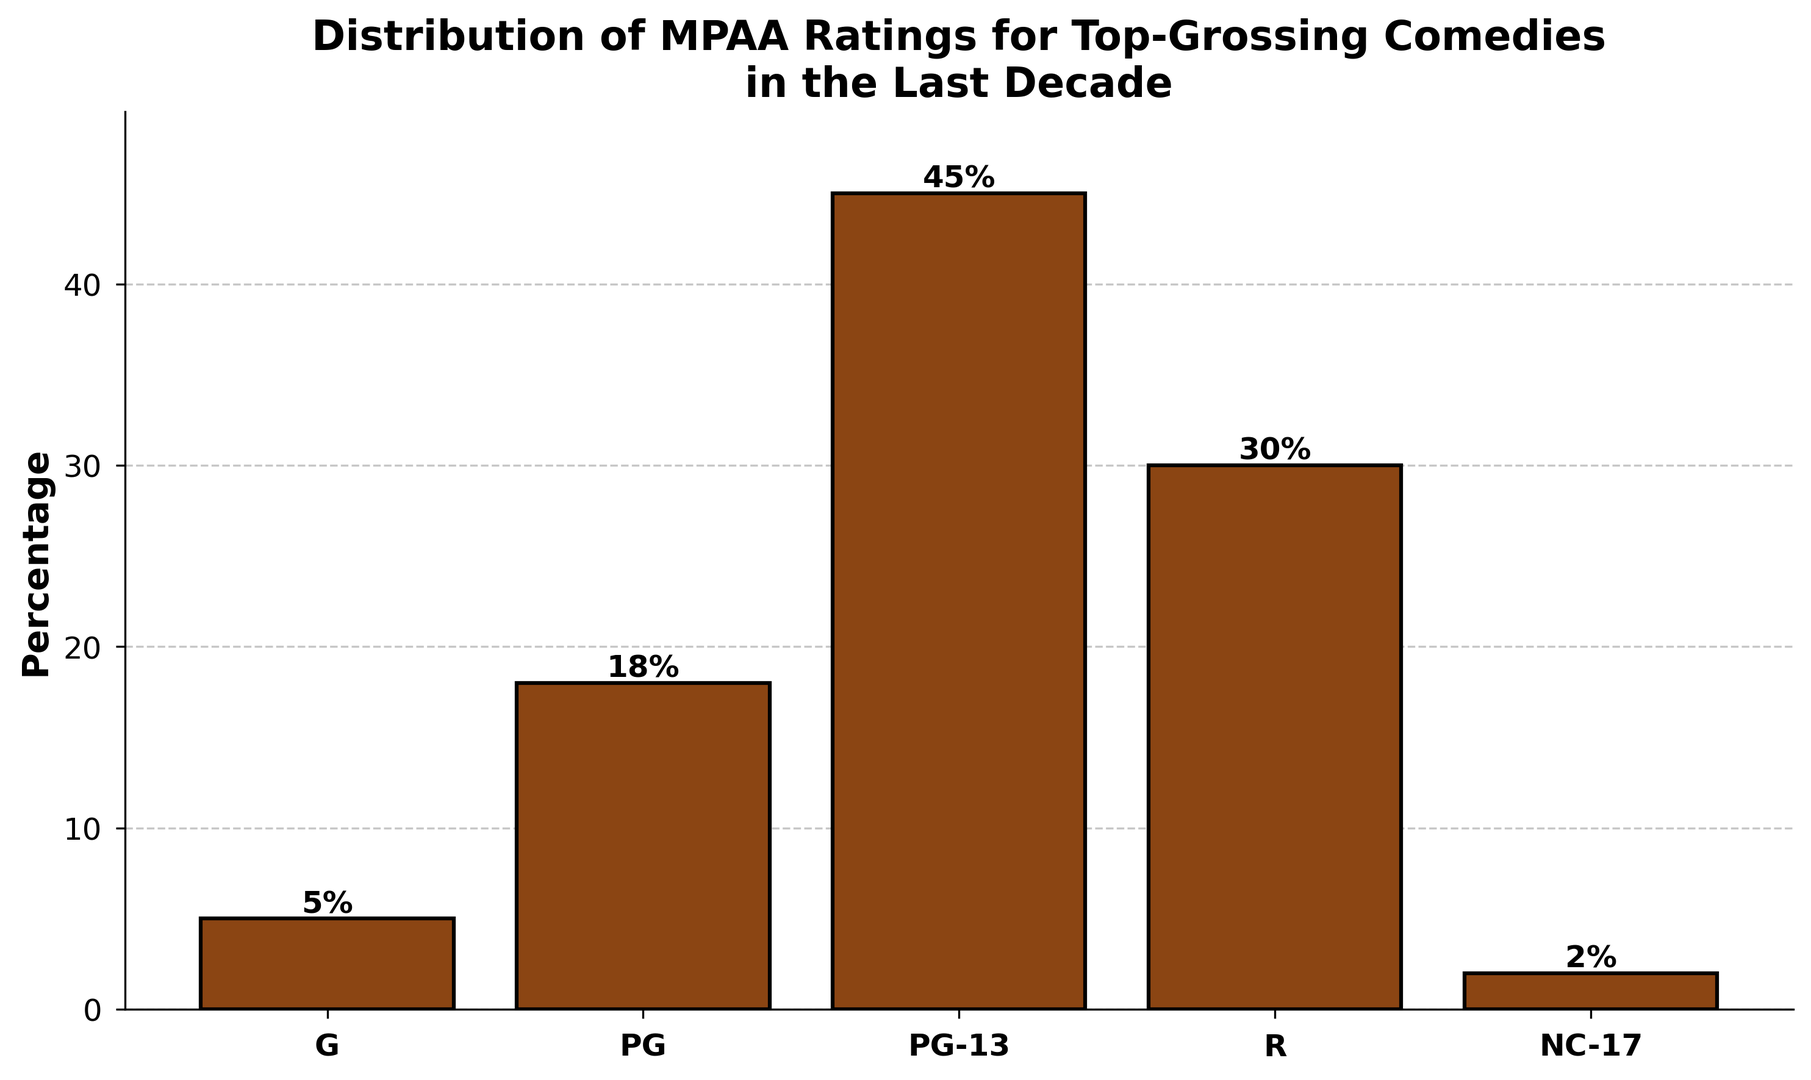What percentage of top-grossing comedies have a PG-13 rating? The bar labeled "PG-13" has a height indicating 45%.
Answer: 45% What is the total percentage of top-grossing comedies that are rated G or PG? The bar labeled "G" indicates 5%, and the bar labeled "PG" indicates 18%. Adding them together: 5% + 18% = 23%
Answer: 23% Which rating category has the smallest percentage of top-grossing comedies? The bar labeled "NC-17" has the smallest height, which is 2%.
Answer: NC-17 By how much does the percentage of PG-13 rated comedies exceed that of R-rated comedies? The bar labeled "PG-13" is 45%, and the bar labeled "R" is 30%. The difference is: 45% - 30% = 15%
Answer: 15% What is the combined percentage of top-grossing comedies that are rated either R or NC-17? The bar labeled "R" is 30%, and the bar labeled "NC-17" is 2%. Adding them together: 30% + 2% = 32%
Answer: 32% Among G, PG, and PG-13 rated comedies, which rating dominates the distribution? The bar labeled "PG-13" has the largest height among G (5%), PG (18%), and PG-13 (45%).
Answer: PG-13 What is the difference in percentage points between the most frequent rating and the least frequent rating? The most frequent rating is PG-13 at 45%, and the least frequent is NC-17 at 2%. The difference is: 45% - 2% = 43%
Answer: 43% Does the sum of percentages for R and NC-17 rated comedies exceed the percentage of PG rated comedies? The sum of R and NC-17 is 30% + 2% = 32%. The percentage for PG is 18%. Since 32% > 18%, yes, it exceeds.
Answer: Yes What visual attributes are used to emphasize each bar on the chart? Each bar uses a consistent brown color with a black edge and has labels displaying their respective percentages above them. Additionally, the bars have a slight 3D effect due to shading.
Answer: Brown color, black edges, percentage labels 